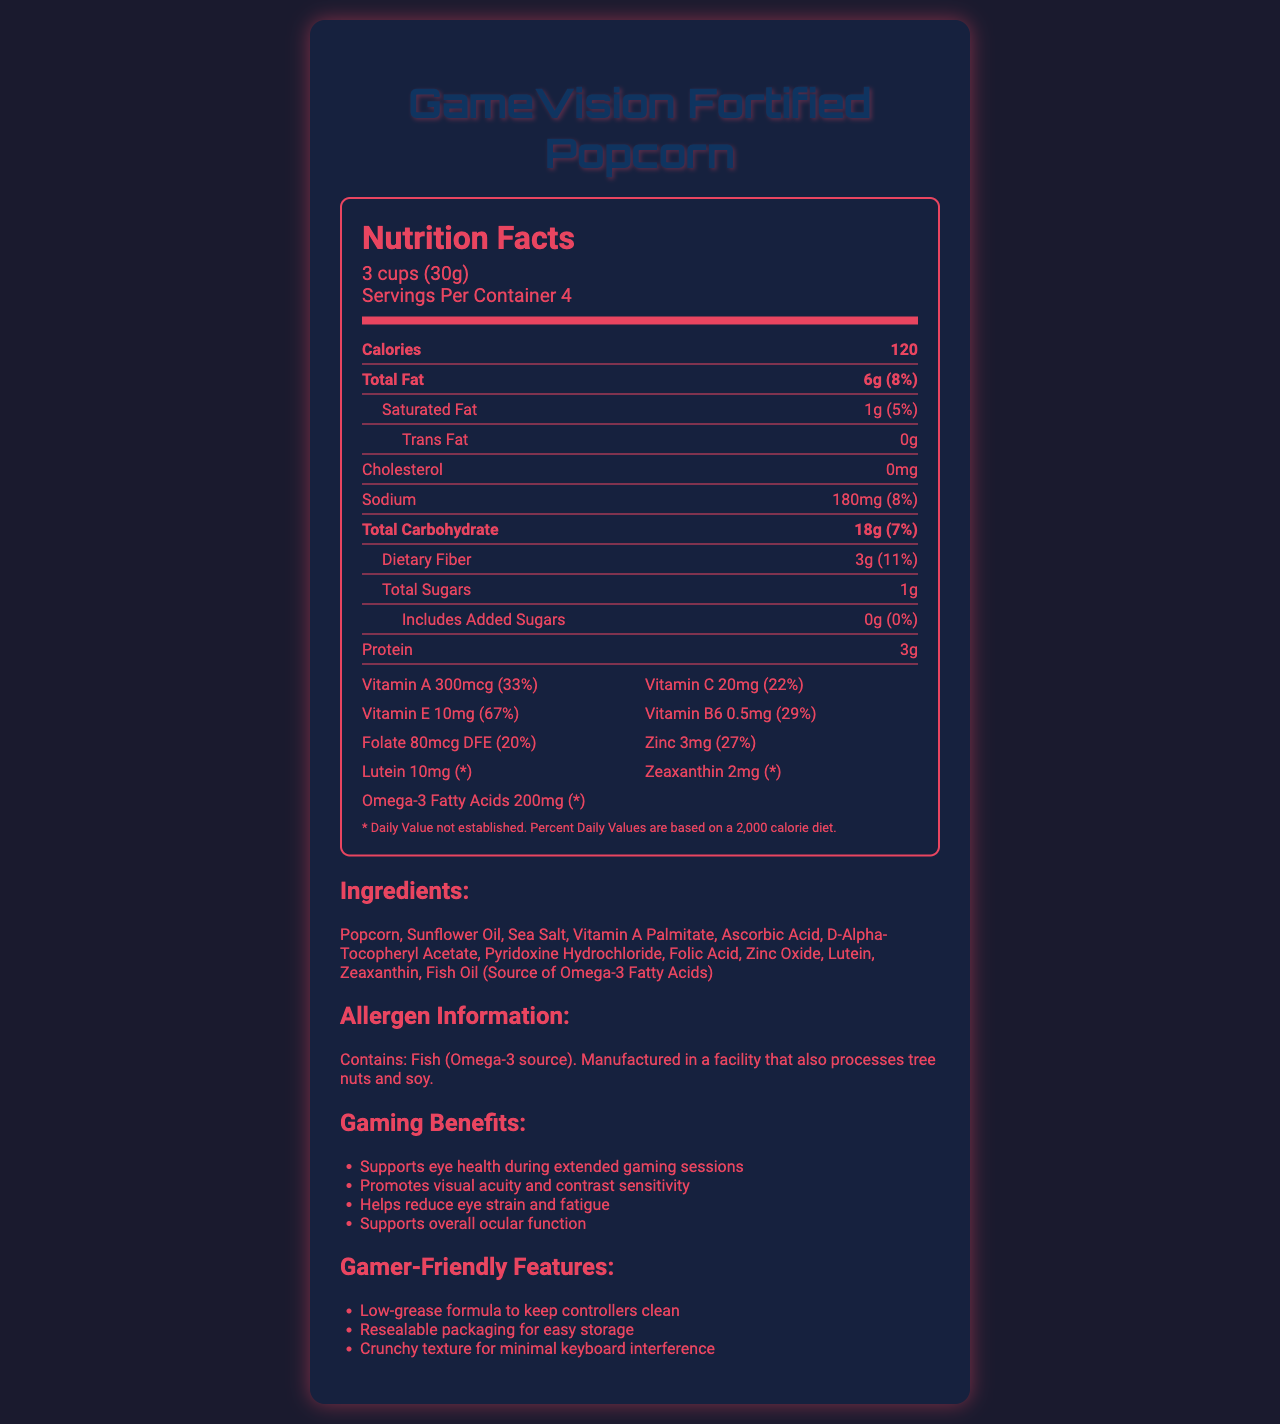how many servings are in a container of GameVision Fortified Popcorn? The label indicates that there are "Servings Per Container 4."
Answer: 4 what is the amount of Vitamin A per serving? The label lists Vitamin A as 300mcg per serving.
Answer: 300mcg what percentage of the Daily Value of Vitamin E does one serving provide? The label states that Vitamin E provides 67% of the Daily Value per serving.
Answer: 67% how much cholesterol is in one serving? The document indicates that there is 0mg of cholesterol in one serving.
Answer: 0mg how much sodium is in a serving of this popcorn? The sodium content per serving is 180mg, as stated in the label.
Answer: 180mg what is the total carbohydrate content per serving? The label lists total carbohydrate content as 18g per serving.
Answer: 18g does this product contain any trans fat? The label states "Trans Fat 0g," indicating there is no trans fat in the product.
Answer: No which of the following vitamins or minerals is not listed on the GameVision Fortified Popcorn label? A. Vitamin D B. Folate C. Vitamin B6 D. Zinc The label mentions Folate, Vitamin B6, and Zinc, but not Vitamin D.
Answer: A how much protein is in one serving of GameVision Fortified Popcorn? The document lists the protein content as 3g per serving.
Answer: 3g which of the following benefits is not claimed by the product? i. Supports eye health during gaming ii. Increases energy levels iii. Promotes visual acuity The document does not mention increasing energy levels as a claimed benefit.
Answer: ii is the product manufactured in a facility that also processes soy? The allergen information states that it is "Manufactured in a facility that also processes tree nuts and soy."
Answer: Yes describe the main idea of the document. It specifies various vitamins and minerals included to support eye health during extended screen time and outlines gamer-friendly features such as low-grease formula and resealable packaging.
Answer: The document provides detailed nutritional information, ingredients, allergen information, and gaming benefits for GameVision Fortified Popcorn. how many grams of dietary fiber are in one serving? The label indicates that one serving contains 3g of dietary fiber.
Answer: 3g can you determine the exact manufacturing location of the product from the document? The document does not provide specific information about the manufacturing location.
Answer: No is this product suitable for individuals with fish allergies? The allergen info states that it contains fish (Omega-3 source), making it unsuitable for individuals with fish allergies.
Answer: No 